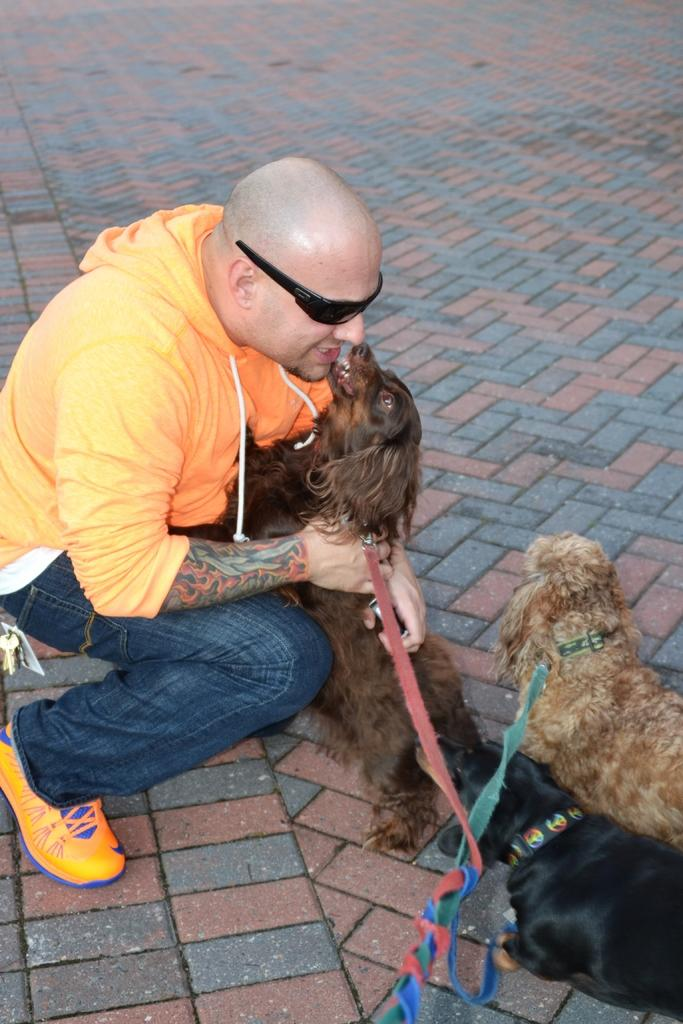Who or what is the main subject in the image? There is a person in the image. What is the person doing in the image? The person is holding a dog. Are there any other animals visible in the image? Yes, there are two other dogs visible in the image. What type of basin can be seen in the image? There is no basin present in the image. What time of day is depicted in the image? The time of day is not mentioned in the provided facts, so it cannot be determined from the image. 